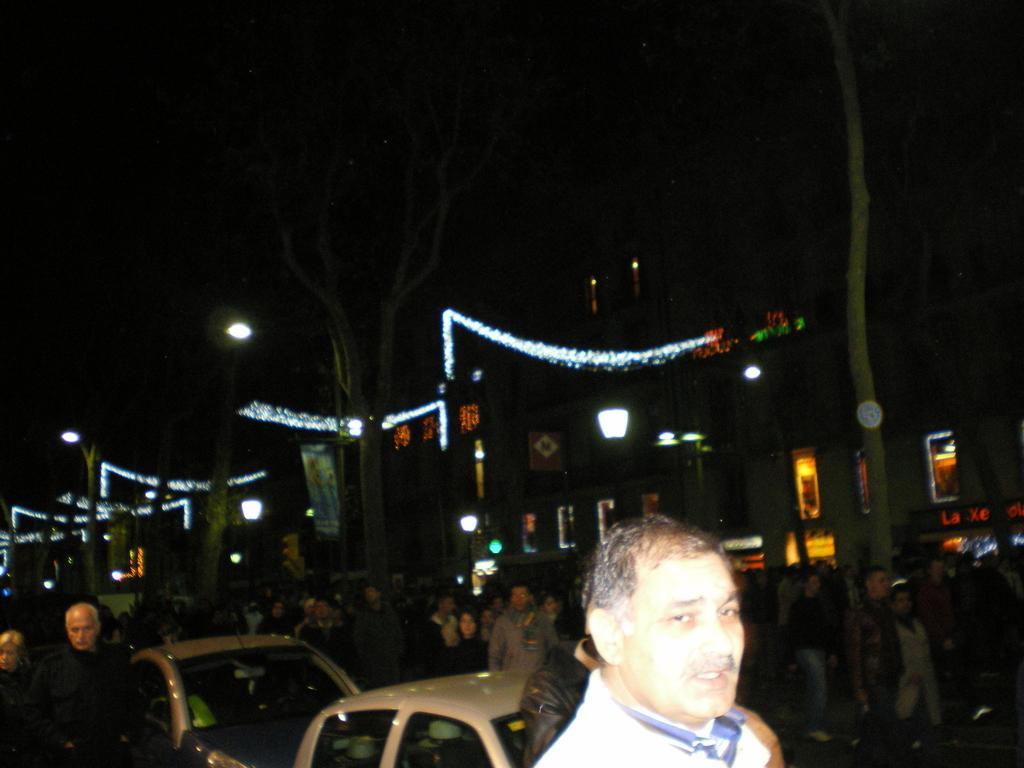How would you summarize this image in a sentence or two? In this picture we can see people, vehicles, and trees. Behind the people, there are street lights, decorative lights, a banner and buildings. Behind the buildings, there is a dark background. 